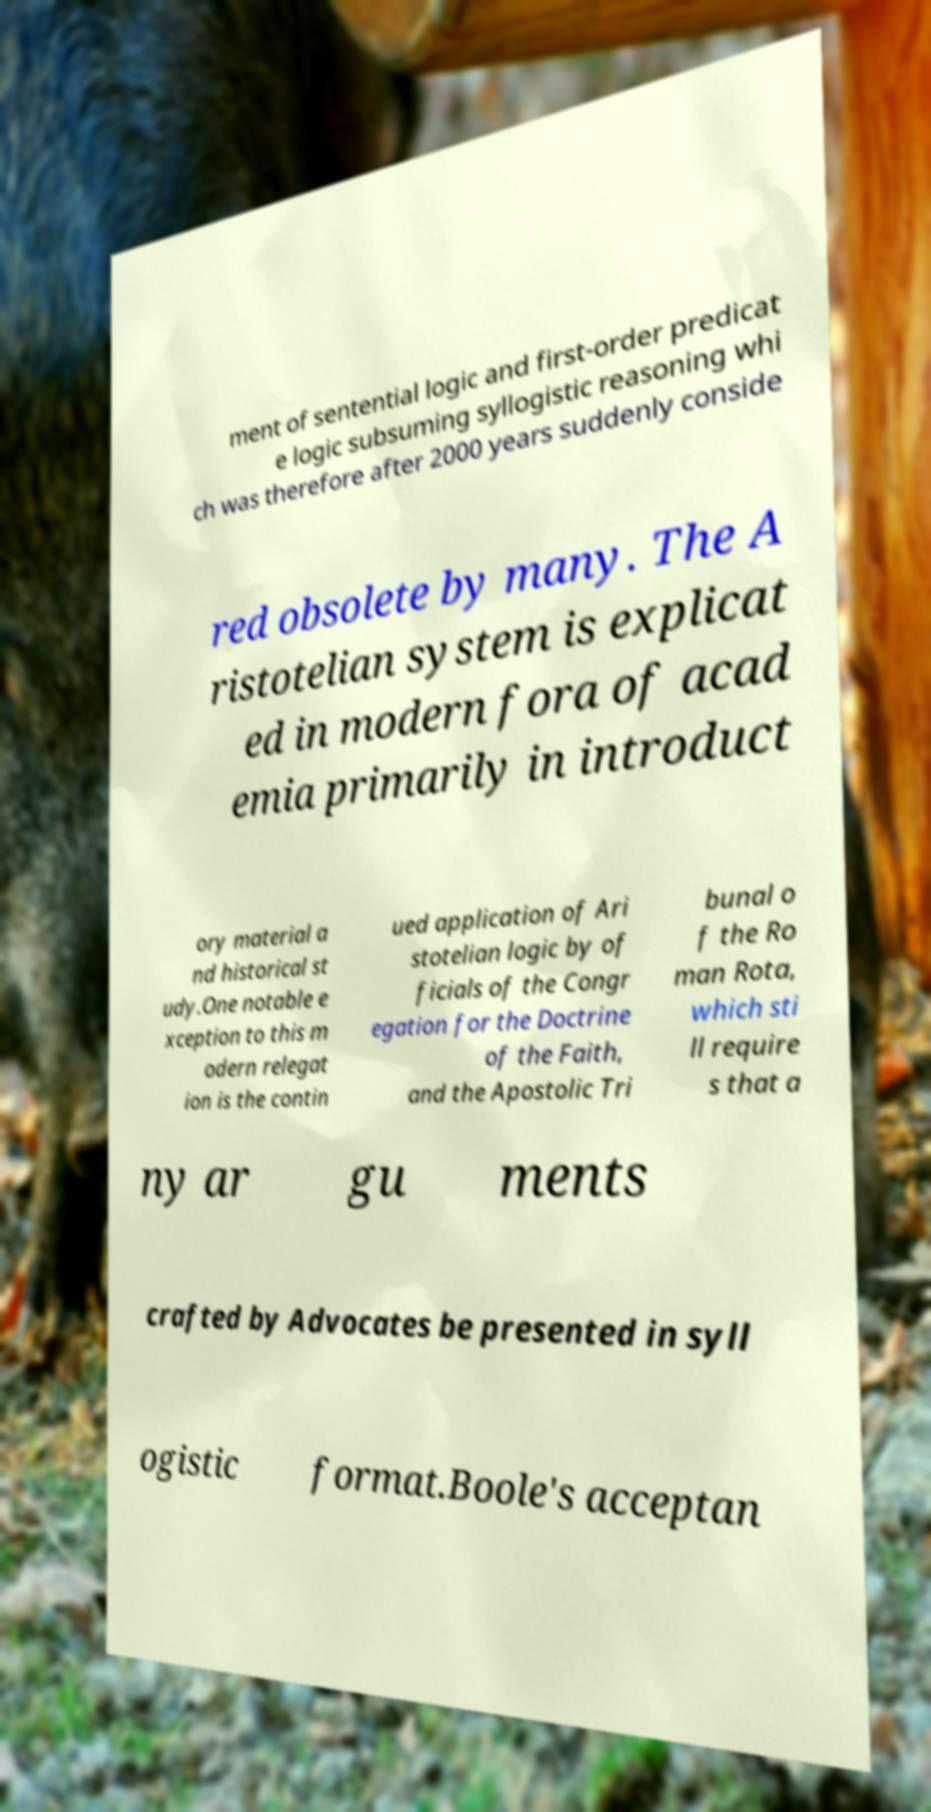What messages or text are displayed in this image? I need them in a readable, typed format. ment of sentential logic and first-order predicat e logic subsuming syllogistic reasoning whi ch was therefore after 2000 years suddenly conside red obsolete by many. The A ristotelian system is explicat ed in modern fora of acad emia primarily in introduct ory material a nd historical st udy.One notable e xception to this m odern relegat ion is the contin ued application of Ari stotelian logic by of ficials of the Congr egation for the Doctrine of the Faith, and the Apostolic Tri bunal o f the Ro man Rota, which sti ll require s that a ny ar gu ments crafted by Advocates be presented in syll ogistic format.Boole's acceptan 